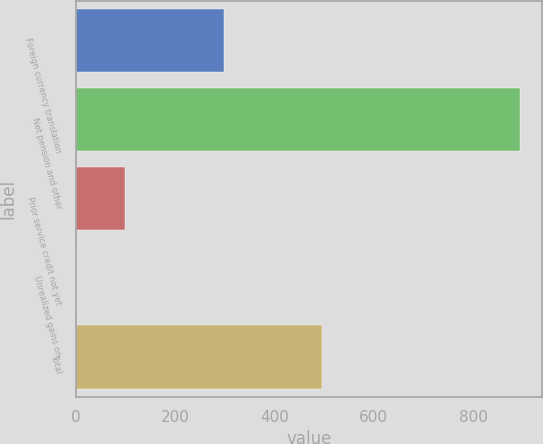Convert chart. <chart><loc_0><loc_0><loc_500><loc_500><bar_chart><fcel>Foreign currency translation<fcel>Net pension and other<fcel>Prior service credit not yet<fcel>Unrealized gains on<fcel>Total<nl><fcel>298<fcel>894<fcel>99<fcel>1<fcel>495<nl></chart> 